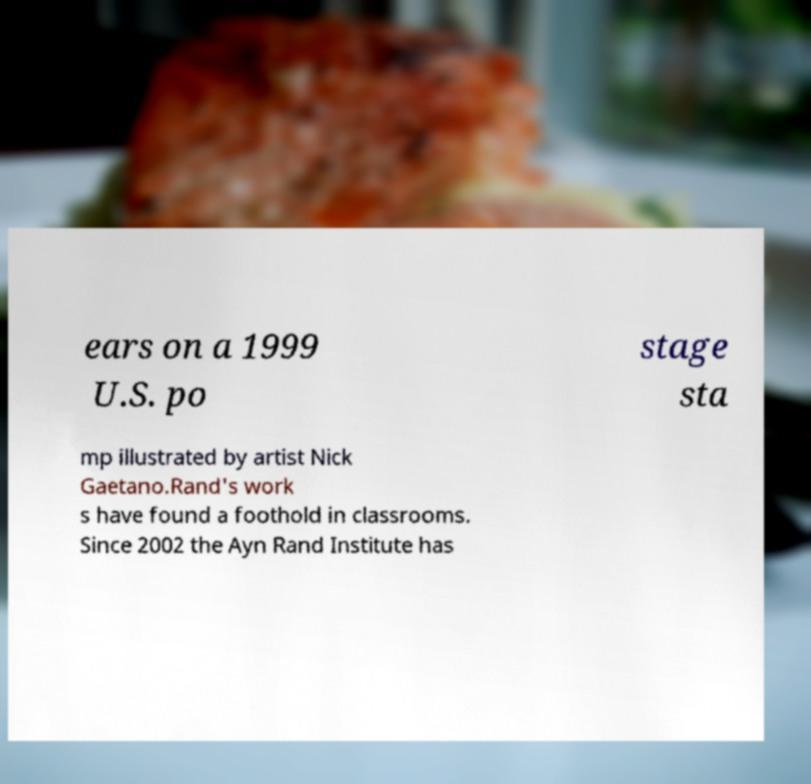Can you read and provide the text displayed in the image?This photo seems to have some interesting text. Can you extract and type it out for me? ears on a 1999 U.S. po stage sta mp illustrated by artist Nick Gaetano.Rand's work s have found a foothold in classrooms. Since 2002 the Ayn Rand Institute has 